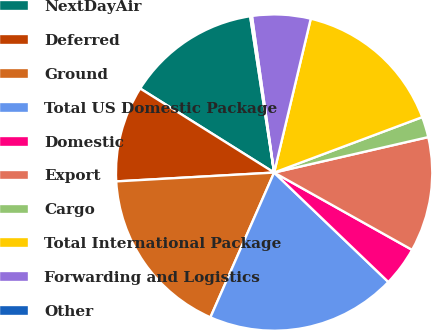Convert chart. <chart><loc_0><loc_0><loc_500><loc_500><pie_chart><fcel>NextDayAir<fcel>Deferred<fcel>Ground<fcel>Total US Domestic Package<fcel>Domestic<fcel>Export<fcel>Cargo<fcel>Total International Package<fcel>Forwarding and Logistics<fcel>Other<nl><fcel>13.66%<fcel>9.81%<fcel>17.51%<fcel>19.44%<fcel>4.03%<fcel>11.73%<fcel>2.1%<fcel>15.58%<fcel>5.96%<fcel>0.18%<nl></chart> 